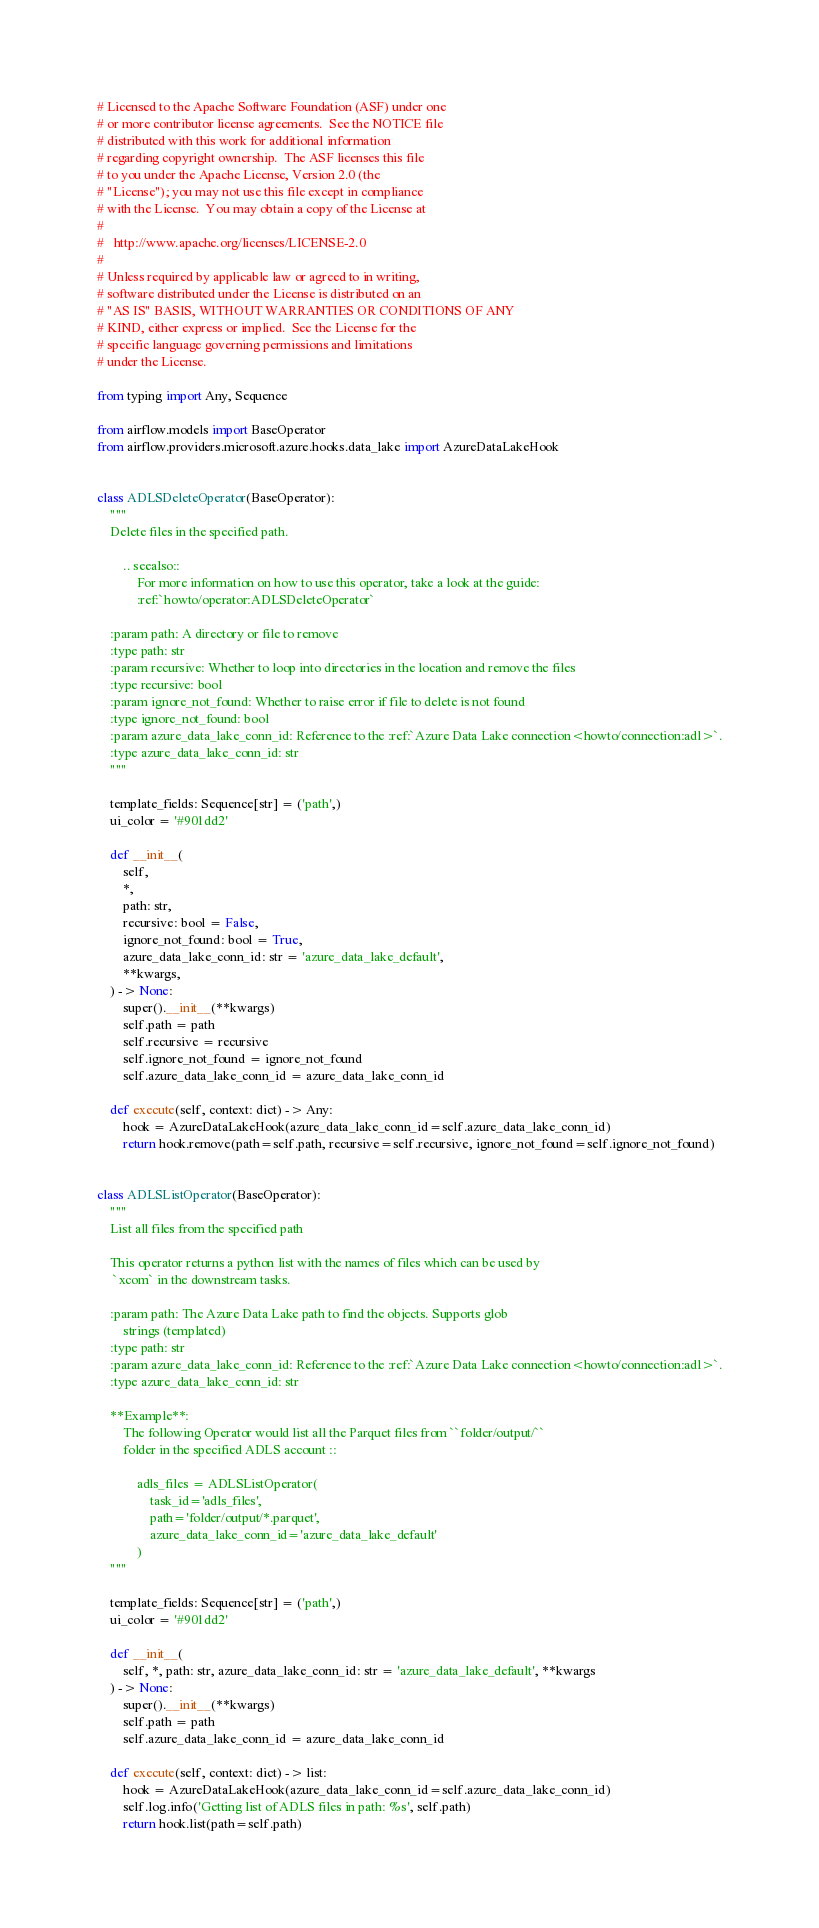Convert code to text. <code><loc_0><loc_0><loc_500><loc_500><_Python_># Licensed to the Apache Software Foundation (ASF) under one
# or more contributor license agreements.  See the NOTICE file
# distributed with this work for additional information
# regarding copyright ownership.  The ASF licenses this file
# to you under the Apache License, Version 2.0 (the
# "License"); you may not use this file except in compliance
# with the License.  You may obtain a copy of the License at
#
#   http://www.apache.org/licenses/LICENSE-2.0
#
# Unless required by applicable law or agreed to in writing,
# software distributed under the License is distributed on an
# "AS IS" BASIS, WITHOUT WARRANTIES OR CONDITIONS OF ANY
# KIND, either express or implied.  See the License for the
# specific language governing permissions and limitations
# under the License.

from typing import Any, Sequence

from airflow.models import BaseOperator
from airflow.providers.microsoft.azure.hooks.data_lake import AzureDataLakeHook


class ADLSDeleteOperator(BaseOperator):
    """
    Delete files in the specified path.

        .. seealso::
            For more information on how to use this operator, take a look at the guide:
            :ref:`howto/operator:ADLSDeleteOperator`

    :param path: A directory or file to remove
    :type path: str
    :param recursive: Whether to loop into directories in the location and remove the files
    :type recursive: bool
    :param ignore_not_found: Whether to raise error if file to delete is not found
    :type ignore_not_found: bool
    :param azure_data_lake_conn_id: Reference to the :ref:`Azure Data Lake connection<howto/connection:adl>`.
    :type azure_data_lake_conn_id: str
    """

    template_fields: Sequence[str] = ('path',)
    ui_color = '#901dd2'

    def __init__(
        self,
        *,
        path: str,
        recursive: bool = False,
        ignore_not_found: bool = True,
        azure_data_lake_conn_id: str = 'azure_data_lake_default',
        **kwargs,
    ) -> None:
        super().__init__(**kwargs)
        self.path = path
        self.recursive = recursive
        self.ignore_not_found = ignore_not_found
        self.azure_data_lake_conn_id = azure_data_lake_conn_id

    def execute(self, context: dict) -> Any:
        hook = AzureDataLakeHook(azure_data_lake_conn_id=self.azure_data_lake_conn_id)
        return hook.remove(path=self.path, recursive=self.recursive, ignore_not_found=self.ignore_not_found)


class ADLSListOperator(BaseOperator):
    """
    List all files from the specified path

    This operator returns a python list with the names of files which can be used by
     `xcom` in the downstream tasks.

    :param path: The Azure Data Lake path to find the objects. Supports glob
        strings (templated)
    :type path: str
    :param azure_data_lake_conn_id: Reference to the :ref:`Azure Data Lake connection<howto/connection:adl>`.
    :type azure_data_lake_conn_id: str

    **Example**:
        The following Operator would list all the Parquet files from ``folder/output/``
        folder in the specified ADLS account ::

            adls_files = ADLSListOperator(
                task_id='adls_files',
                path='folder/output/*.parquet',
                azure_data_lake_conn_id='azure_data_lake_default'
            )
    """

    template_fields: Sequence[str] = ('path',)
    ui_color = '#901dd2'

    def __init__(
        self, *, path: str, azure_data_lake_conn_id: str = 'azure_data_lake_default', **kwargs
    ) -> None:
        super().__init__(**kwargs)
        self.path = path
        self.azure_data_lake_conn_id = azure_data_lake_conn_id

    def execute(self, context: dict) -> list:
        hook = AzureDataLakeHook(azure_data_lake_conn_id=self.azure_data_lake_conn_id)
        self.log.info('Getting list of ADLS files in path: %s', self.path)
        return hook.list(path=self.path)
</code> 